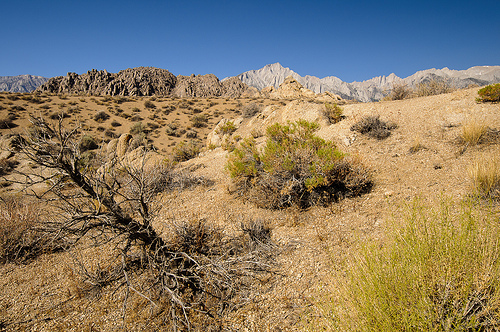<image>
Is the mountains in the desert? Yes. The mountains is contained within or inside the desert, showing a containment relationship. 